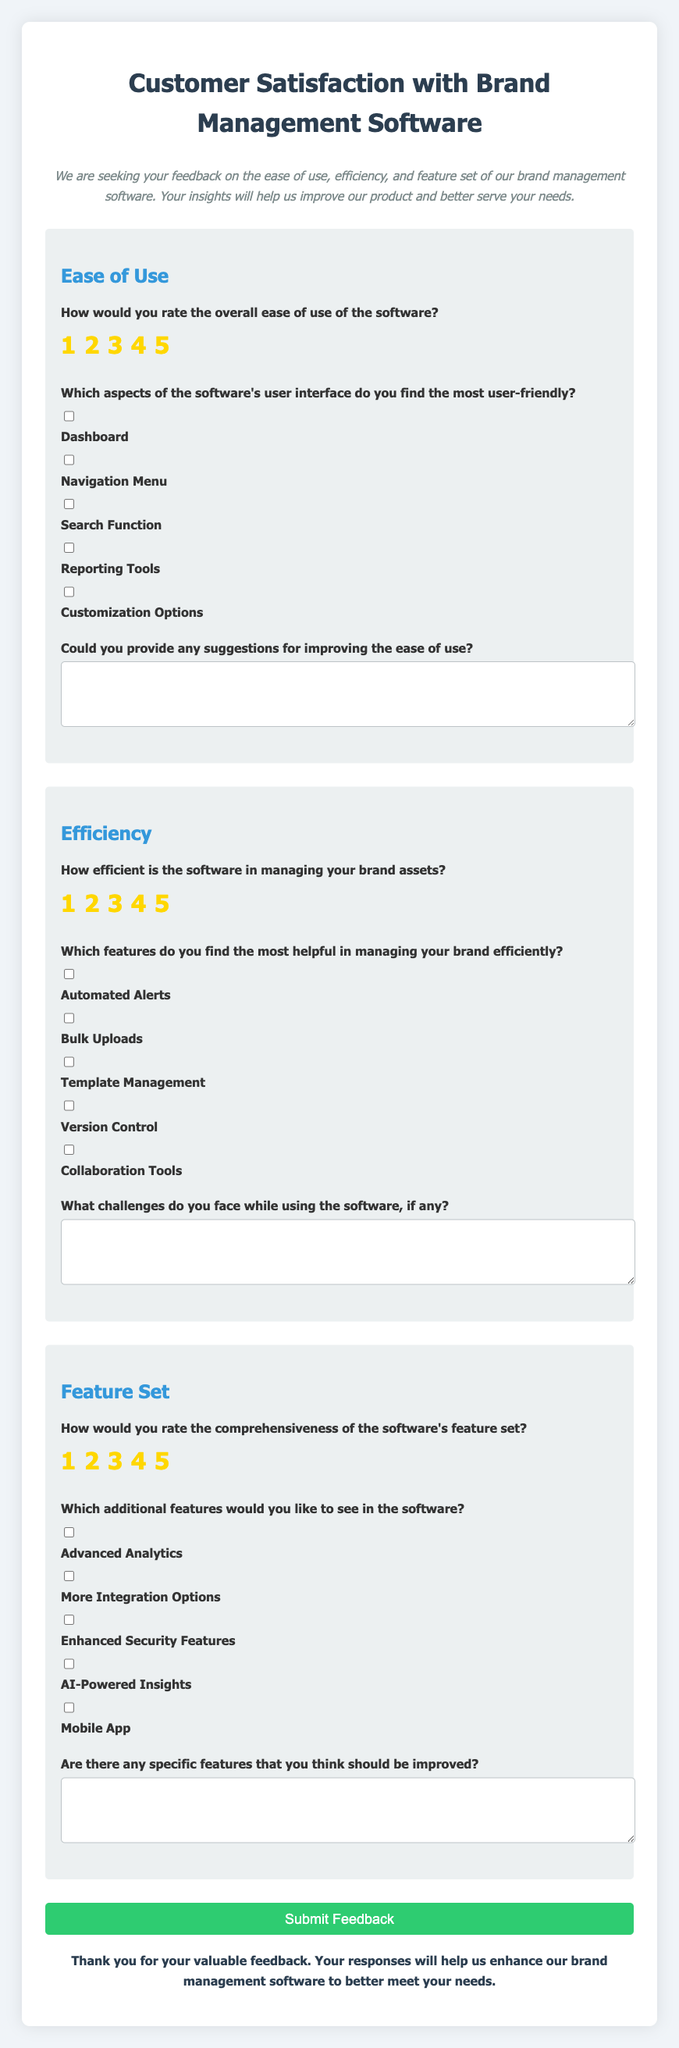What is the title of the survey? The title of the survey is prominently displayed at the top of the document, indicating its purpose.
Answer: Customer Satisfaction with Brand Management Software How many sections are in the survey? The survey is divided into three main sections focusing on different aspects of the software.
Answer: 3 What is the highest rating possible for the ease of use? The ease of use section includes a rating system where respondents can score the software's usability.
Answer: 5 Which feature is included in the Efficiency section for managing brands? The Efficiency section lists various tools that assist in efficient brand management.
Answer: Automated Alerts What type of feedback does the survey seek from users? The survey requests various opinions from users to enhance the software.
Answer: Suggestions for improvements What is the color of the submit button? The color of the submit button is designed to stand out and attract user interaction.
Answer: Green Are users asked to provide additional feature requests? The survey includes a question prompting users to share desired features they would like to see added.
Answer: Yes How does the survey thank participants? A thank-you note is provided at the bottom of the survey to appreciate participants' time and feedback.
Answer: Thank you for your valuable feedback What is the action taken when the form is submitted? The JavaScript embedded in the document handles form submission by preventing the default action and prompting an alert.
Answer: Alert message 